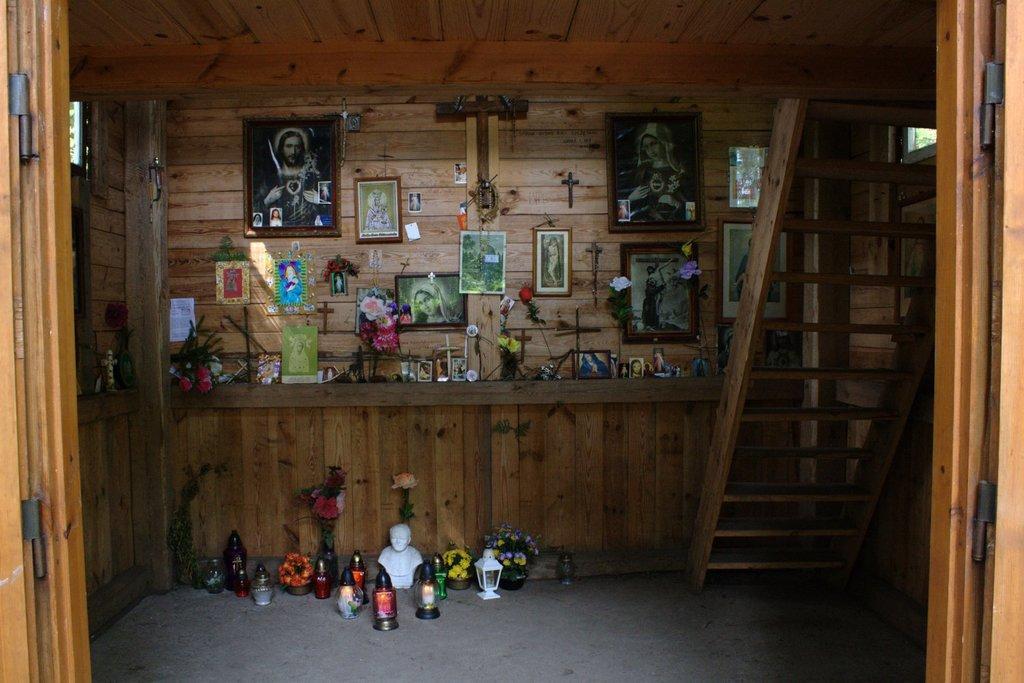How would you summarize this image in a sentence or two? This image is clicked inside a room. There are stairs on the right side. There are so many photo frames in the middle. There are flower vases in the middle. 